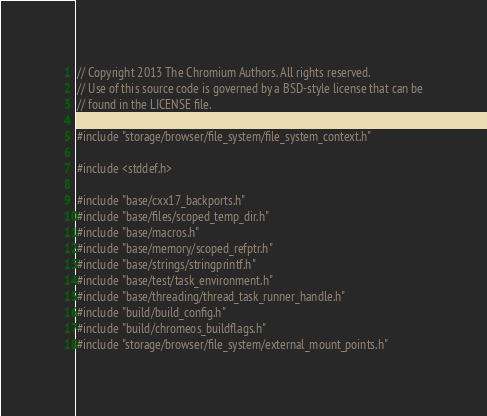Convert code to text. <code><loc_0><loc_0><loc_500><loc_500><_C++_>// Copyright 2013 The Chromium Authors. All rights reserved.
// Use of this source code is governed by a BSD-style license that can be
// found in the LICENSE file.

#include "storage/browser/file_system/file_system_context.h"

#include <stddef.h>

#include "base/cxx17_backports.h"
#include "base/files/scoped_temp_dir.h"
#include "base/macros.h"
#include "base/memory/scoped_refptr.h"
#include "base/strings/stringprintf.h"
#include "base/test/task_environment.h"
#include "base/threading/thread_task_runner_handle.h"
#include "build/build_config.h"
#include "build/chromeos_buildflags.h"
#include "storage/browser/file_system/external_mount_points.h"</code> 